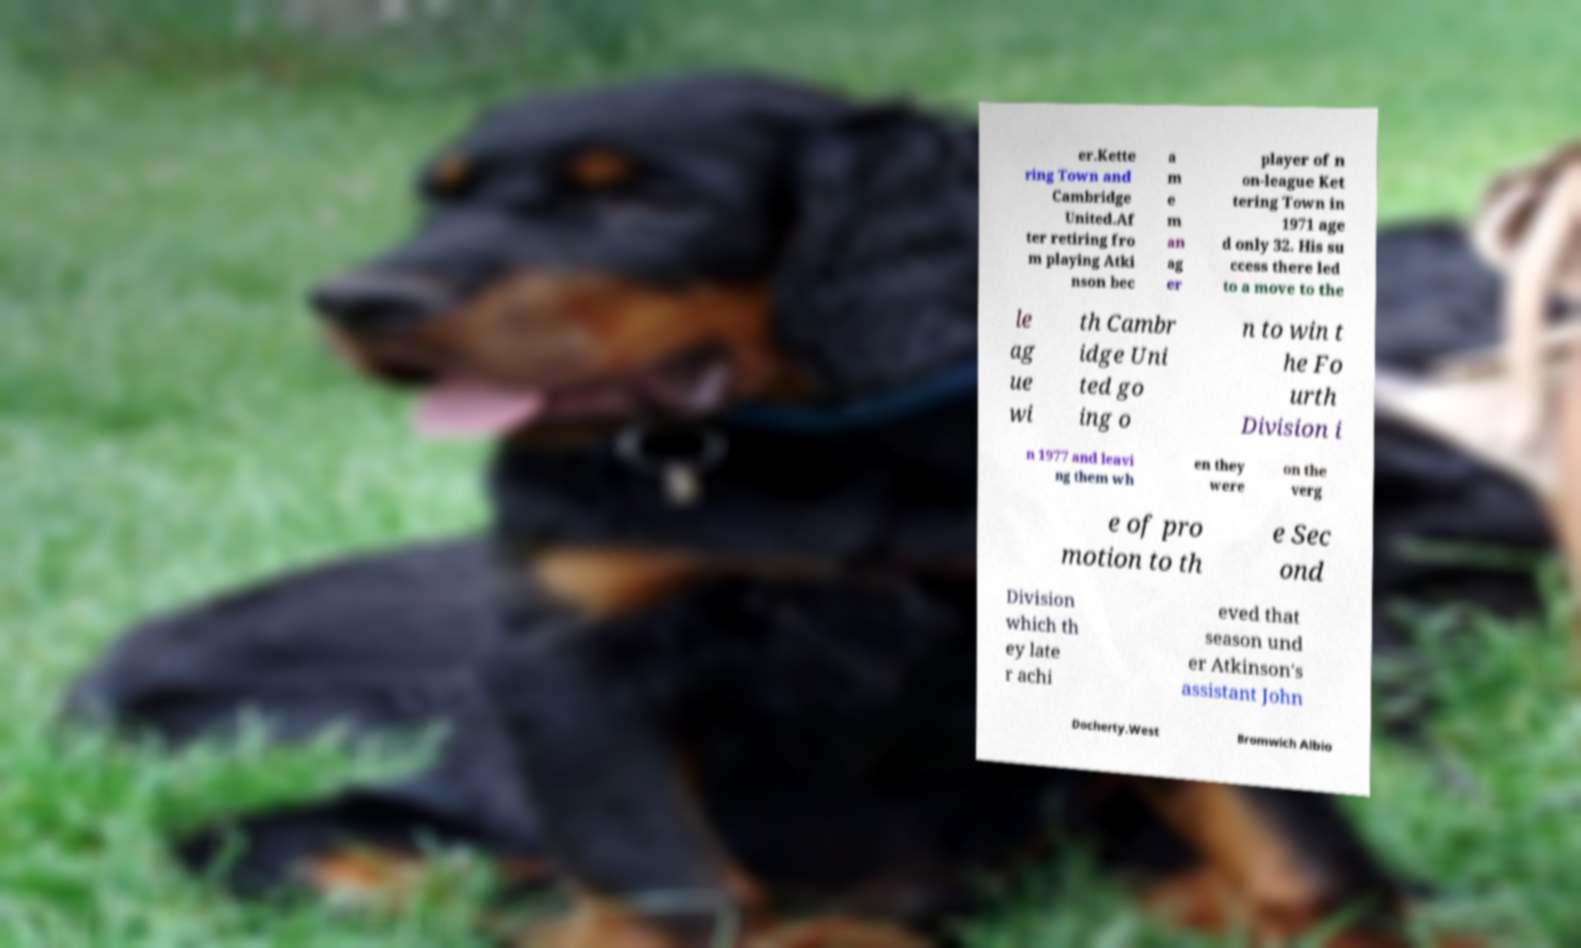Please identify and transcribe the text found in this image. er.Kette ring Town and Cambridge United.Af ter retiring fro m playing Atki nson bec a m e m an ag er player of n on-league Ket tering Town in 1971 age d only 32. His su ccess there led to a move to the le ag ue wi th Cambr idge Uni ted go ing o n to win t he Fo urth Division i n 1977 and leavi ng them wh en they were on the verg e of pro motion to th e Sec ond Division which th ey late r achi eved that season und er Atkinson's assistant John Docherty.West Bromwich Albio 